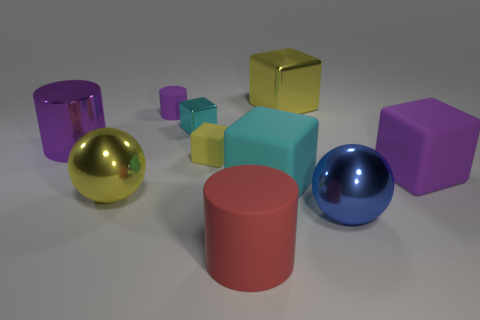Subtract all blue cubes. Subtract all blue spheres. How many cubes are left? 5 Subtract all balls. How many objects are left? 8 Add 6 purple cylinders. How many purple cylinders exist? 8 Subtract 1 blue spheres. How many objects are left? 9 Subtract all red cylinders. Subtract all small blocks. How many objects are left? 7 Add 2 purple matte cylinders. How many purple matte cylinders are left? 3 